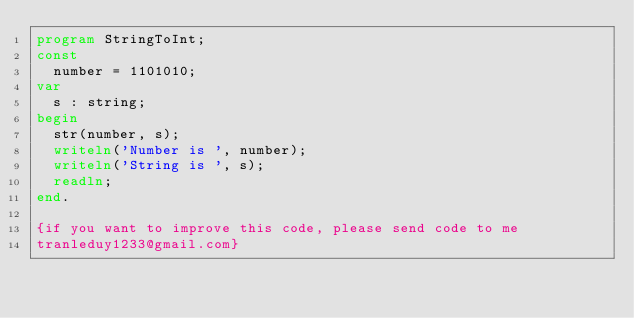<code> <loc_0><loc_0><loc_500><loc_500><_Pascal_>program StringToInt;
const
  number = 1101010;
var
  s : string;
begin
  str(number, s);
  writeln('Number is ', number);
  writeln('String is ', s);
  readln;
end.

{if you want to improve this code, please send code to me
tranleduy1233@gmail.com}</code> 